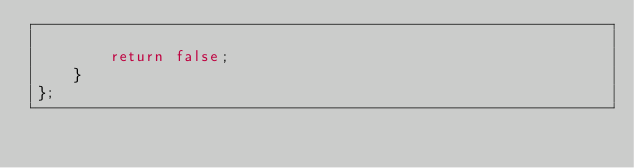Convert code to text. <code><loc_0><loc_0><loc_500><loc_500><_C++_>        
        return false;
    }
};
</code> 